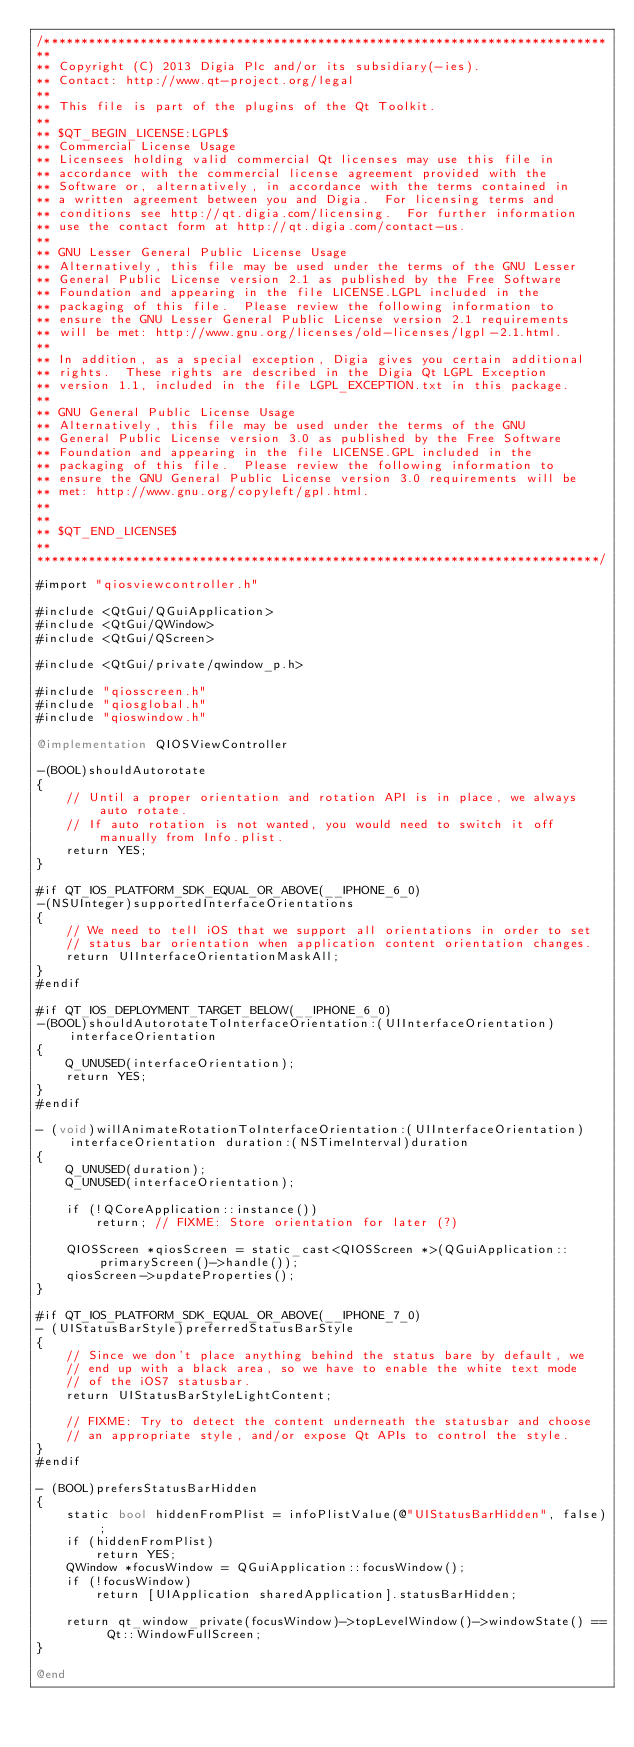Convert code to text. <code><loc_0><loc_0><loc_500><loc_500><_ObjectiveC_>/****************************************************************************
**
** Copyright (C) 2013 Digia Plc and/or its subsidiary(-ies).
** Contact: http://www.qt-project.org/legal
**
** This file is part of the plugins of the Qt Toolkit.
**
** $QT_BEGIN_LICENSE:LGPL$
** Commercial License Usage
** Licensees holding valid commercial Qt licenses may use this file in
** accordance with the commercial license agreement provided with the
** Software or, alternatively, in accordance with the terms contained in
** a written agreement between you and Digia.  For licensing terms and
** conditions see http://qt.digia.com/licensing.  For further information
** use the contact form at http://qt.digia.com/contact-us.
**
** GNU Lesser General Public License Usage
** Alternatively, this file may be used under the terms of the GNU Lesser
** General Public License version 2.1 as published by the Free Software
** Foundation and appearing in the file LICENSE.LGPL included in the
** packaging of this file.  Please review the following information to
** ensure the GNU Lesser General Public License version 2.1 requirements
** will be met: http://www.gnu.org/licenses/old-licenses/lgpl-2.1.html.
**
** In addition, as a special exception, Digia gives you certain additional
** rights.  These rights are described in the Digia Qt LGPL Exception
** version 1.1, included in the file LGPL_EXCEPTION.txt in this package.
**
** GNU General Public License Usage
** Alternatively, this file may be used under the terms of the GNU
** General Public License version 3.0 as published by the Free Software
** Foundation and appearing in the file LICENSE.GPL included in the
** packaging of this file.  Please review the following information to
** ensure the GNU General Public License version 3.0 requirements will be
** met: http://www.gnu.org/copyleft/gpl.html.
**
**
** $QT_END_LICENSE$
**
****************************************************************************/

#import "qiosviewcontroller.h"

#include <QtGui/QGuiApplication>
#include <QtGui/QWindow>
#include <QtGui/QScreen>

#include <QtGui/private/qwindow_p.h>

#include "qiosscreen.h"
#include "qiosglobal.h"
#include "qioswindow.h"

@implementation QIOSViewController

-(BOOL)shouldAutorotate
{
    // Until a proper orientation and rotation API is in place, we always auto rotate.
    // If auto rotation is not wanted, you would need to switch it off manually from Info.plist.
    return YES;
}

#if QT_IOS_PLATFORM_SDK_EQUAL_OR_ABOVE(__IPHONE_6_0)
-(NSUInteger)supportedInterfaceOrientations
{
    // We need to tell iOS that we support all orientations in order to set
    // status bar orientation when application content orientation changes.
    return UIInterfaceOrientationMaskAll;
}
#endif

#if QT_IOS_DEPLOYMENT_TARGET_BELOW(__IPHONE_6_0)
-(BOOL)shouldAutorotateToInterfaceOrientation:(UIInterfaceOrientation)interfaceOrientation
{
    Q_UNUSED(interfaceOrientation);
    return YES;
}
#endif

- (void)willAnimateRotationToInterfaceOrientation:(UIInterfaceOrientation)interfaceOrientation duration:(NSTimeInterval)duration
{
    Q_UNUSED(duration);
    Q_UNUSED(interfaceOrientation);

    if (!QCoreApplication::instance())
        return; // FIXME: Store orientation for later (?)

    QIOSScreen *qiosScreen = static_cast<QIOSScreen *>(QGuiApplication::primaryScreen()->handle());
    qiosScreen->updateProperties();
}

#if QT_IOS_PLATFORM_SDK_EQUAL_OR_ABOVE(__IPHONE_7_0)
- (UIStatusBarStyle)preferredStatusBarStyle
{
    // Since we don't place anything behind the status bare by default, we
    // end up with a black area, so we have to enable the white text mode
    // of the iOS7 statusbar.
    return UIStatusBarStyleLightContent;

    // FIXME: Try to detect the content underneath the statusbar and choose
    // an appropriate style, and/or expose Qt APIs to control the style.
}
#endif

- (BOOL)prefersStatusBarHidden
{
    static bool hiddenFromPlist = infoPlistValue(@"UIStatusBarHidden", false);
    if (hiddenFromPlist)
        return YES;
    QWindow *focusWindow = QGuiApplication::focusWindow();
    if (!focusWindow)
        return [UIApplication sharedApplication].statusBarHidden;

    return qt_window_private(focusWindow)->topLevelWindow()->windowState() == Qt::WindowFullScreen;
}

@end

</code> 